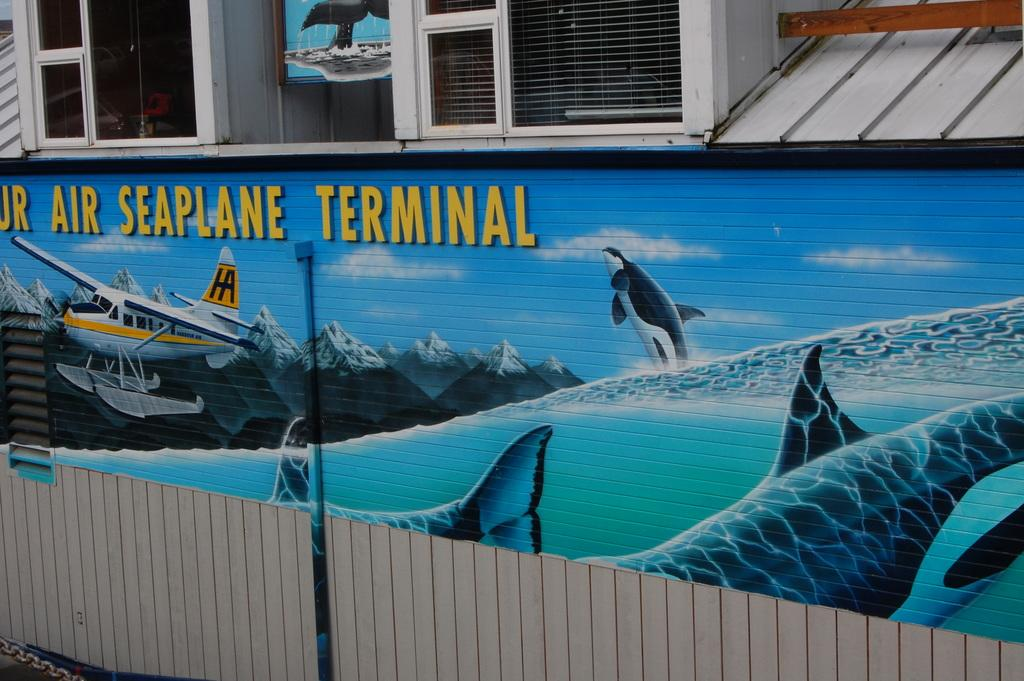What type of structure is present in the image? There is a structure that resembles a building in the image. What features can be observed on the building? The building has windows and a wall with a painting. What is the material of the object that looks like a stick? The wooden stick in the image is made of wood. What is written at the bottom of the wall? There is text at the bottom of the wall. Can you see any insects crawling on the building in the image? There are no insects visible in the image. What type of crack is present on the wall of the building? There is no crack visible on the wall of the building in the image. 